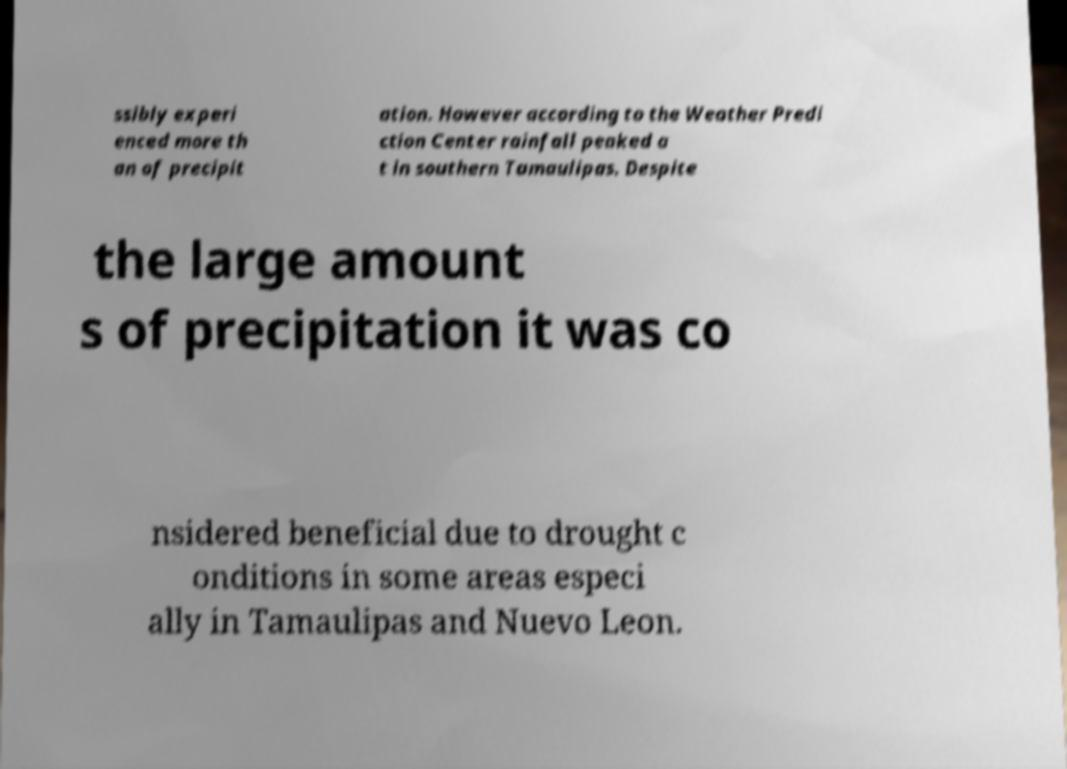There's text embedded in this image that I need extracted. Can you transcribe it verbatim? ssibly experi enced more th an of precipit ation. However according to the Weather Predi ction Center rainfall peaked a t in southern Tamaulipas. Despite the large amount s of precipitation it was co nsidered beneficial due to drought c onditions in some areas especi ally in Tamaulipas and Nuevo Leon. 